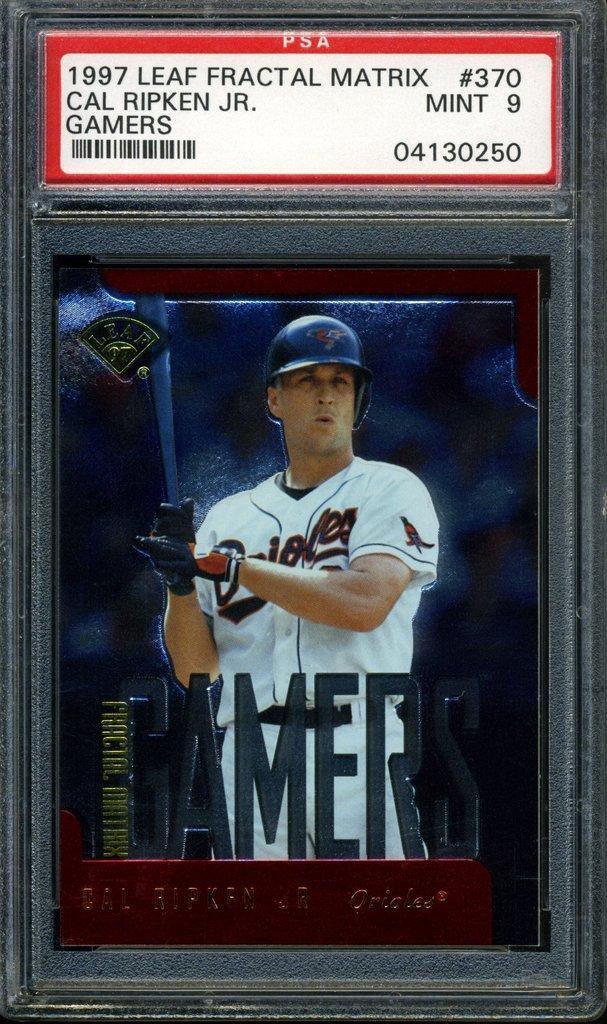Provide a one-sentence caption for the provided image. Baseball card which says Gamers on it in the front. 